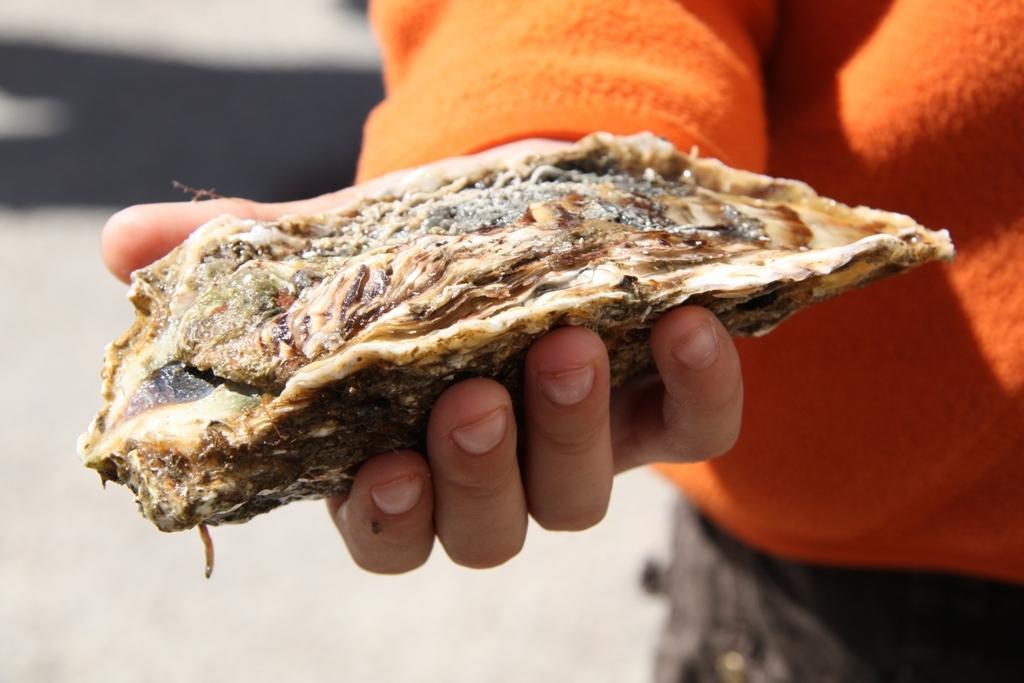Could you give a brief overview of what you see in this image? Here I can see a person standing and holding an object in the hands which seems to be a food item. The background is blurred. 